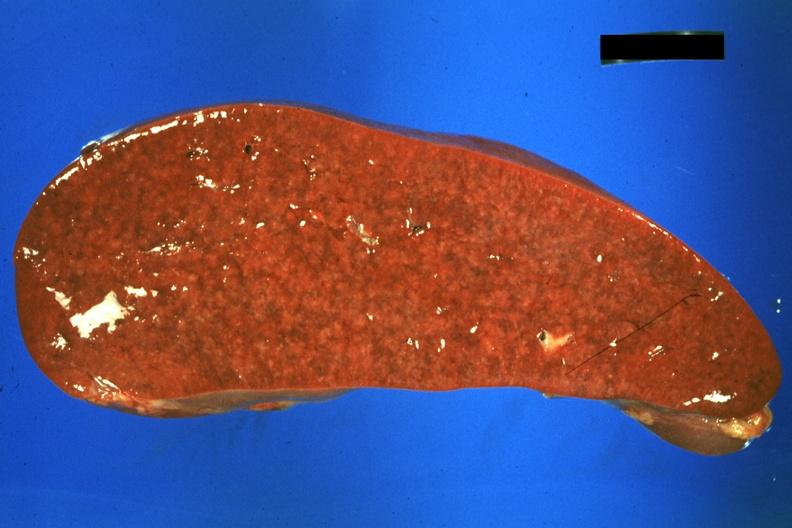does surface show cut surface?
Answer the question using a single word or phrase. No 